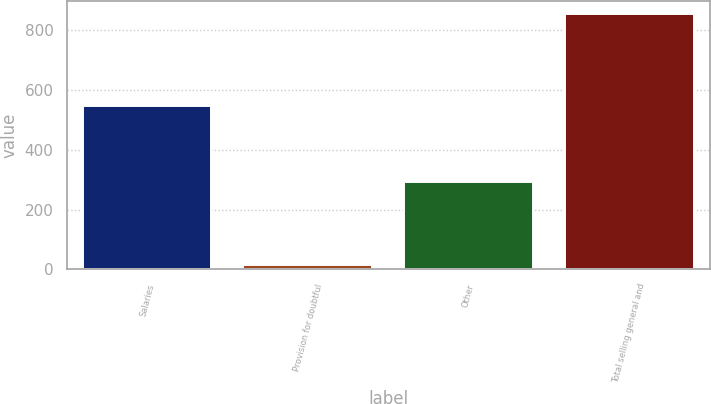<chart> <loc_0><loc_0><loc_500><loc_500><bar_chart><fcel>Salaries<fcel>Provision for doubtful<fcel>Other<fcel>Total selling general and<nl><fcel>545.4<fcel>16.1<fcel>292.3<fcel>853.8<nl></chart> 